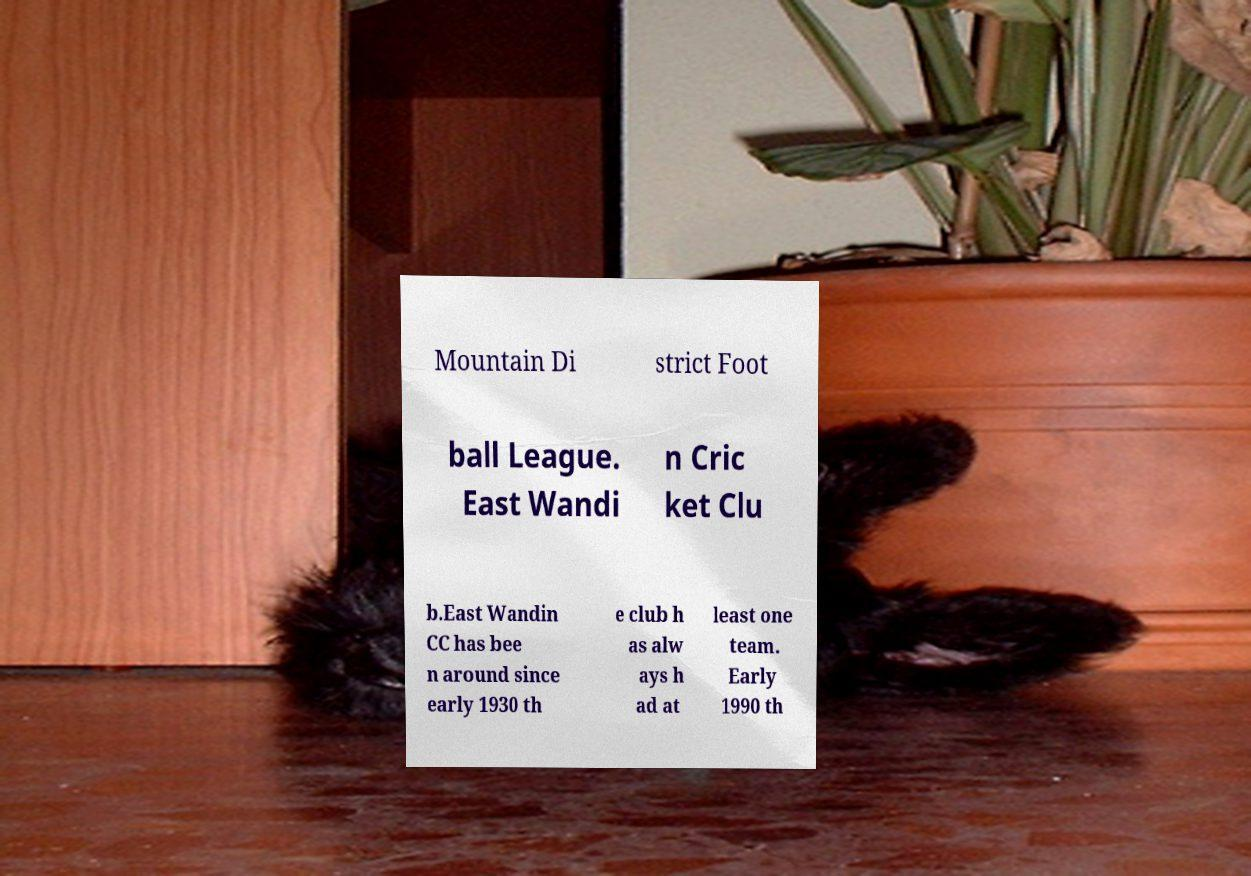Could you extract and type out the text from this image? Mountain Di strict Foot ball League. East Wandi n Cric ket Clu b.East Wandin CC has bee n around since early 1930 th e club h as alw ays h ad at least one team. Early 1990 th 